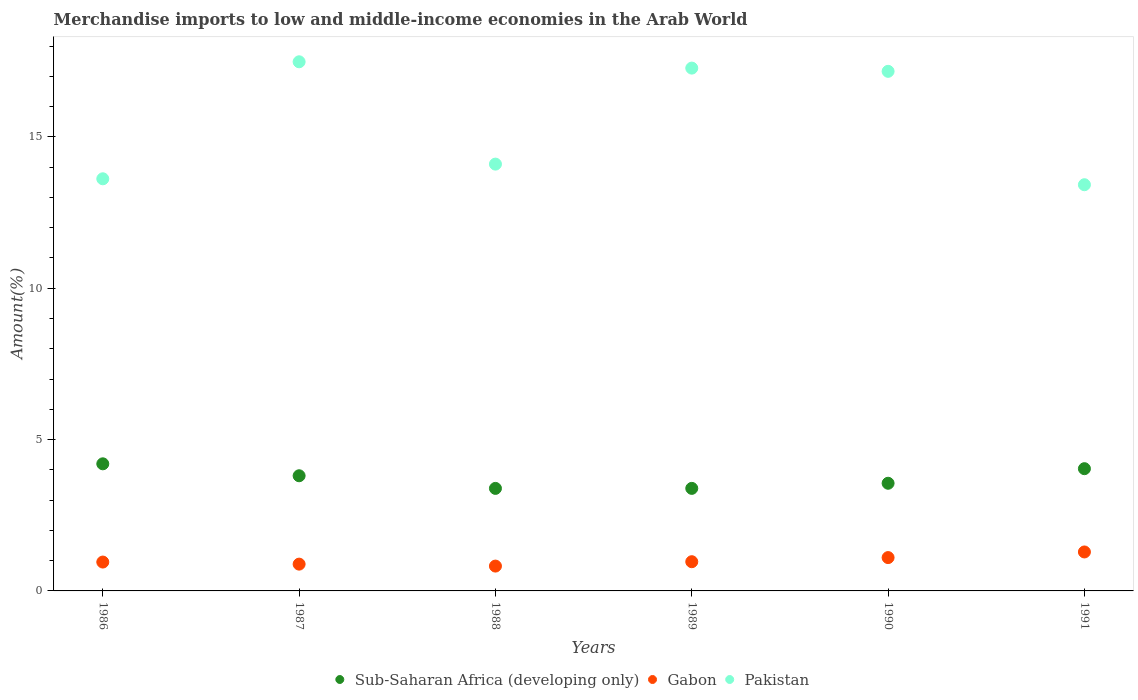How many different coloured dotlines are there?
Give a very brief answer. 3. What is the percentage of amount earned from merchandise imports in Sub-Saharan Africa (developing only) in 1991?
Your answer should be compact. 4.04. Across all years, what is the maximum percentage of amount earned from merchandise imports in Gabon?
Offer a very short reply. 1.29. Across all years, what is the minimum percentage of amount earned from merchandise imports in Pakistan?
Provide a succinct answer. 13.42. In which year was the percentage of amount earned from merchandise imports in Sub-Saharan Africa (developing only) maximum?
Offer a very short reply. 1986. What is the total percentage of amount earned from merchandise imports in Sub-Saharan Africa (developing only) in the graph?
Your answer should be very brief. 22.37. What is the difference between the percentage of amount earned from merchandise imports in Sub-Saharan Africa (developing only) in 1986 and that in 1987?
Offer a terse response. 0.39. What is the difference between the percentage of amount earned from merchandise imports in Gabon in 1991 and the percentage of amount earned from merchandise imports in Pakistan in 1990?
Offer a very short reply. -15.88. What is the average percentage of amount earned from merchandise imports in Sub-Saharan Africa (developing only) per year?
Keep it short and to the point. 3.73. In the year 1987, what is the difference between the percentage of amount earned from merchandise imports in Pakistan and percentage of amount earned from merchandise imports in Gabon?
Provide a succinct answer. 16.6. In how many years, is the percentage of amount earned from merchandise imports in Pakistan greater than 15 %?
Your answer should be compact. 3. What is the ratio of the percentage of amount earned from merchandise imports in Pakistan in 1986 to that in 1989?
Your response must be concise. 0.79. What is the difference between the highest and the second highest percentage of amount earned from merchandise imports in Pakistan?
Give a very brief answer. 0.21. What is the difference between the highest and the lowest percentage of amount earned from merchandise imports in Sub-Saharan Africa (developing only)?
Offer a terse response. 0.81. Is the sum of the percentage of amount earned from merchandise imports in Gabon in 1990 and 1991 greater than the maximum percentage of amount earned from merchandise imports in Pakistan across all years?
Your response must be concise. No. Is it the case that in every year, the sum of the percentage of amount earned from merchandise imports in Gabon and percentage of amount earned from merchandise imports in Sub-Saharan Africa (developing only)  is greater than the percentage of amount earned from merchandise imports in Pakistan?
Provide a short and direct response. No. Does the percentage of amount earned from merchandise imports in Sub-Saharan Africa (developing only) monotonically increase over the years?
Your answer should be compact. No. Is the percentage of amount earned from merchandise imports in Sub-Saharan Africa (developing only) strictly less than the percentage of amount earned from merchandise imports in Pakistan over the years?
Make the answer very short. Yes. What is the difference between two consecutive major ticks on the Y-axis?
Ensure brevity in your answer.  5. Does the graph contain any zero values?
Keep it short and to the point. No. Does the graph contain grids?
Your answer should be compact. No. How are the legend labels stacked?
Make the answer very short. Horizontal. What is the title of the graph?
Ensure brevity in your answer.  Merchandise imports to low and middle-income economies in the Arab World. Does "Bahrain" appear as one of the legend labels in the graph?
Your answer should be compact. No. What is the label or title of the X-axis?
Make the answer very short. Years. What is the label or title of the Y-axis?
Offer a terse response. Amount(%). What is the Amount(%) of Sub-Saharan Africa (developing only) in 1986?
Provide a succinct answer. 4.2. What is the Amount(%) in Gabon in 1986?
Your response must be concise. 0.95. What is the Amount(%) of Pakistan in 1986?
Your answer should be compact. 13.62. What is the Amount(%) of Sub-Saharan Africa (developing only) in 1987?
Give a very brief answer. 3.8. What is the Amount(%) in Gabon in 1987?
Make the answer very short. 0.89. What is the Amount(%) of Pakistan in 1987?
Keep it short and to the point. 17.48. What is the Amount(%) in Sub-Saharan Africa (developing only) in 1988?
Ensure brevity in your answer.  3.39. What is the Amount(%) of Gabon in 1988?
Your response must be concise. 0.82. What is the Amount(%) of Pakistan in 1988?
Your answer should be very brief. 14.1. What is the Amount(%) of Sub-Saharan Africa (developing only) in 1989?
Your answer should be compact. 3.39. What is the Amount(%) of Gabon in 1989?
Keep it short and to the point. 0.97. What is the Amount(%) in Pakistan in 1989?
Give a very brief answer. 17.27. What is the Amount(%) in Sub-Saharan Africa (developing only) in 1990?
Make the answer very short. 3.56. What is the Amount(%) of Gabon in 1990?
Your answer should be compact. 1.1. What is the Amount(%) of Pakistan in 1990?
Your response must be concise. 17.17. What is the Amount(%) in Sub-Saharan Africa (developing only) in 1991?
Ensure brevity in your answer.  4.04. What is the Amount(%) in Gabon in 1991?
Your response must be concise. 1.29. What is the Amount(%) of Pakistan in 1991?
Your response must be concise. 13.42. Across all years, what is the maximum Amount(%) in Sub-Saharan Africa (developing only)?
Your answer should be very brief. 4.2. Across all years, what is the maximum Amount(%) in Gabon?
Your answer should be very brief. 1.29. Across all years, what is the maximum Amount(%) in Pakistan?
Offer a very short reply. 17.48. Across all years, what is the minimum Amount(%) in Sub-Saharan Africa (developing only)?
Ensure brevity in your answer.  3.39. Across all years, what is the minimum Amount(%) in Gabon?
Make the answer very short. 0.82. Across all years, what is the minimum Amount(%) of Pakistan?
Offer a very short reply. 13.42. What is the total Amount(%) in Sub-Saharan Africa (developing only) in the graph?
Offer a terse response. 22.37. What is the total Amount(%) in Gabon in the graph?
Your answer should be compact. 6.01. What is the total Amount(%) of Pakistan in the graph?
Your answer should be very brief. 93.05. What is the difference between the Amount(%) in Sub-Saharan Africa (developing only) in 1986 and that in 1987?
Your answer should be compact. 0.39. What is the difference between the Amount(%) of Gabon in 1986 and that in 1987?
Provide a succinct answer. 0.07. What is the difference between the Amount(%) of Pakistan in 1986 and that in 1987?
Provide a succinct answer. -3.87. What is the difference between the Amount(%) in Sub-Saharan Africa (developing only) in 1986 and that in 1988?
Make the answer very short. 0.81. What is the difference between the Amount(%) in Gabon in 1986 and that in 1988?
Your response must be concise. 0.13. What is the difference between the Amount(%) in Pakistan in 1986 and that in 1988?
Give a very brief answer. -0.48. What is the difference between the Amount(%) in Sub-Saharan Africa (developing only) in 1986 and that in 1989?
Your response must be concise. 0.81. What is the difference between the Amount(%) in Gabon in 1986 and that in 1989?
Your answer should be compact. -0.01. What is the difference between the Amount(%) of Pakistan in 1986 and that in 1989?
Your answer should be very brief. -3.66. What is the difference between the Amount(%) of Sub-Saharan Africa (developing only) in 1986 and that in 1990?
Provide a short and direct response. 0.64. What is the difference between the Amount(%) of Gabon in 1986 and that in 1990?
Offer a very short reply. -0.15. What is the difference between the Amount(%) in Pakistan in 1986 and that in 1990?
Keep it short and to the point. -3.55. What is the difference between the Amount(%) of Sub-Saharan Africa (developing only) in 1986 and that in 1991?
Ensure brevity in your answer.  0.16. What is the difference between the Amount(%) of Gabon in 1986 and that in 1991?
Keep it short and to the point. -0.33. What is the difference between the Amount(%) of Pakistan in 1986 and that in 1991?
Your response must be concise. 0.2. What is the difference between the Amount(%) in Sub-Saharan Africa (developing only) in 1987 and that in 1988?
Keep it short and to the point. 0.42. What is the difference between the Amount(%) in Gabon in 1987 and that in 1988?
Provide a succinct answer. 0.06. What is the difference between the Amount(%) of Pakistan in 1987 and that in 1988?
Offer a very short reply. 3.38. What is the difference between the Amount(%) of Sub-Saharan Africa (developing only) in 1987 and that in 1989?
Your response must be concise. 0.42. What is the difference between the Amount(%) in Gabon in 1987 and that in 1989?
Make the answer very short. -0.08. What is the difference between the Amount(%) of Pakistan in 1987 and that in 1989?
Provide a succinct answer. 0.21. What is the difference between the Amount(%) in Sub-Saharan Africa (developing only) in 1987 and that in 1990?
Offer a very short reply. 0.25. What is the difference between the Amount(%) of Gabon in 1987 and that in 1990?
Your answer should be very brief. -0.22. What is the difference between the Amount(%) in Pakistan in 1987 and that in 1990?
Ensure brevity in your answer.  0.32. What is the difference between the Amount(%) of Sub-Saharan Africa (developing only) in 1987 and that in 1991?
Offer a terse response. -0.23. What is the difference between the Amount(%) of Gabon in 1987 and that in 1991?
Provide a succinct answer. -0.4. What is the difference between the Amount(%) in Pakistan in 1987 and that in 1991?
Give a very brief answer. 4.06. What is the difference between the Amount(%) in Sub-Saharan Africa (developing only) in 1988 and that in 1989?
Your answer should be very brief. -0. What is the difference between the Amount(%) of Gabon in 1988 and that in 1989?
Make the answer very short. -0.14. What is the difference between the Amount(%) of Pakistan in 1988 and that in 1989?
Offer a very short reply. -3.17. What is the difference between the Amount(%) in Sub-Saharan Africa (developing only) in 1988 and that in 1990?
Your response must be concise. -0.17. What is the difference between the Amount(%) of Gabon in 1988 and that in 1990?
Offer a very short reply. -0.28. What is the difference between the Amount(%) in Pakistan in 1988 and that in 1990?
Keep it short and to the point. -3.07. What is the difference between the Amount(%) of Sub-Saharan Africa (developing only) in 1988 and that in 1991?
Your answer should be very brief. -0.65. What is the difference between the Amount(%) in Gabon in 1988 and that in 1991?
Provide a succinct answer. -0.47. What is the difference between the Amount(%) of Pakistan in 1988 and that in 1991?
Offer a very short reply. 0.68. What is the difference between the Amount(%) of Sub-Saharan Africa (developing only) in 1989 and that in 1990?
Your answer should be very brief. -0.17. What is the difference between the Amount(%) in Gabon in 1989 and that in 1990?
Offer a very short reply. -0.14. What is the difference between the Amount(%) of Pakistan in 1989 and that in 1990?
Provide a short and direct response. 0.11. What is the difference between the Amount(%) in Sub-Saharan Africa (developing only) in 1989 and that in 1991?
Make the answer very short. -0.65. What is the difference between the Amount(%) of Gabon in 1989 and that in 1991?
Give a very brief answer. -0.32. What is the difference between the Amount(%) of Pakistan in 1989 and that in 1991?
Your answer should be very brief. 3.85. What is the difference between the Amount(%) in Sub-Saharan Africa (developing only) in 1990 and that in 1991?
Your answer should be very brief. -0.48. What is the difference between the Amount(%) in Gabon in 1990 and that in 1991?
Offer a terse response. -0.19. What is the difference between the Amount(%) of Pakistan in 1990 and that in 1991?
Ensure brevity in your answer.  3.75. What is the difference between the Amount(%) of Sub-Saharan Africa (developing only) in 1986 and the Amount(%) of Gabon in 1987?
Your response must be concise. 3.31. What is the difference between the Amount(%) of Sub-Saharan Africa (developing only) in 1986 and the Amount(%) of Pakistan in 1987?
Your answer should be very brief. -13.28. What is the difference between the Amount(%) in Gabon in 1986 and the Amount(%) in Pakistan in 1987?
Provide a succinct answer. -16.53. What is the difference between the Amount(%) of Sub-Saharan Africa (developing only) in 1986 and the Amount(%) of Gabon in 1988?
Make the answer very short. 3.38. What is the difference between the Amount(%) in Sub-Saharan Africa (developing only) in 1986 and the Amount(%) in Pakistan in 1988?
Your answer should be compact. -9.9. What is the difference between the Amount(%) in Gabon in 1986 and the Amount(%) in Pakistan in 1988?
Make the answer very short. -13.15. What is the difference between the Amount(%) of Sub-Saharan Africa (developing only) in 1986 and the Amount(%) of Gabon in 1989?
Your response must be concise. 3.23. What is the difference between the Amount(%) of Sub-Saharan Africa (developing only) in 1986 and the Amount(%) of Pakistan in 1989?
Provide a succinct answer. -13.07. What is the difference between the Amount(%) of Gabon in 1986 and the Amount(%) of Pakistan in 1989?
Keep it short and to the point. -16.32. What is the difference between the Amount(%) of Sub-Saharan Africa (developing only) in 1986 and the Amount(%) of Gabon in 1990?
Make the answer very short. 3.1. What is the difference between the Amount(%) in Sub-Saharan Africa (developing only) in 1986 and the Amount(%) in Pakistan in 1990?
Your response must be concise. -12.97. What is the difference between the Amount(%) of Gabon in 1986 and the Amount(%) of Pakistan in 1990?
Give a very brief answer. -16.21. What is the difference between the Amount(%) of Sub-Saharan Africa (developing only) in 1986 and the Amount(%) of Gabon in 1991?
Offer a very short reply. 2.91. What is the difference between the Amount(%) in Sub-Saharan Africa (developing only) in 1986 and the Amount(%) in Pakistan in 1991?
Keep it short and to the point. -9.22. What is the difference between the Amount(%) of Gabon in 1986 and the Amount(%) of Pakistan in 1991?
Provide a succinct answer. -12.47. What is the difference between the Amount(%) of Sub-Saharan Africa (developing only) in 1987 and the Amount(%) of Gabon in 1988?
Make the answer very short. 2.98. What is the difference between the Amount(%) of Sub-Saharan Africa (developing only) in 1987 and the Amount(%) of Pakistan in 1988?
Provide a succinct answer. -10.3. What is the difference between the Amount(%) in Gabon in 1987 and the Amount(%) in Pakistan in 1988?
Make the answer very short. -13.22. What is the difference between the Amount(%) in Sub-Saharan Africa (developing only) in 1987 and the Amount(%) in Gabon in 1989?
Offer a very short reply. 2.84. What is the difference between the Amount(%) in Sub-Saharan Africa (developing only) in 1987 and the Amount(%) in Pakistan in 1989?
Keep it short and to the point. -13.47. What is the difference between the Amount(%) in Gabon in 1987 and the Amount(%) in Pakistan in 1989?
Provide a succinct answer. -16.39. What is the difference between the Amount(%) in Sub-Saharan Africa (developing only) in 1987 and the Amount(%) in Gabon in 1990?
Offer a very short reply. 2.7. What is the difference between the Amount(%) of Sub-Saharan Africa (developing only) in 1987 and the Amount(%) of Pakistan in 1990?
Offer a terse response. -13.36. What is the difference between the Amount(%) in Gabon in 1987 and the Amount(%) in Pakistan in 1990?
Your answer should be very brief. -16.28. What is the difference between the Amount(%) of Sub-Saharan Africa (developing only) in 1987 and the Amount(%) of Gabon in 1991?
Your answer should be very brief. 2.52. What is the difference between the Amount(%) in Sub-Saharan Africa (developing only) in 1987 and the Amount(%) in Pakistan in 1991?
Offer a very short reply. -9.61. What is the difference between the Amount(%) of Gabon in 1987 and the Amount(%) of Pakistan in 1991?
Offer a very short reply. -12.53. What is the difference between the Amount(%) of Sub-Saharan Africa (developing only) in 1988 and the Amount(%) of Gabon in 1989?
Provide a short and direct response. 2.42. What is the difference between the Amount(%) in Sub-Saharan Africa (developing only) in 1988 and the Amount(%) in Pakistan in 1989?
Provide a succinct answer. -13.88. What is the difference between the Amount(%) in Gabon in 1988 and the Amount(%) in Pakistan in 1989?
Your answer should be compact. -16.45. What is the difference between the Amount(%) of Sub-Saharan Africa (developing only) in 1988 and the Amount(%) of Gabon in 1990?
Give a very brief answer. 2.29. What is the difference between the Amount(%) in Sub-Saharan Africa (developing only) in 1988 and the Amount(%) in Pakistan in 1990?
Ensure brevity in your answer.  -13.78. What is the difference between the Amount(%) of Gabon in 1988 and the Amount(%) of Pakistan in 1990?
Provide a succinct answer. -16.35. What is the difference between the Amount(%) in Sub-Saharan Africa (developing only) in 1988 and the Amount(%) in Pakistan in 1991?
Ensure brevity in your answer.  -10.03. What is the difference between the Amount(%) of Gabon in 1988 and the Amount(%) of Pakistan in 1991?
Keep it short and to the point. -12.6. What is the difference between the Amount(%) in Sub-Saharan Africa (developing only) in 1989 and the Amount(%) in Gabon in 1990?
Your response must be concise. 2.29. What is the difference between the Amount(%) in Sub-Saharan Africa (developing only) in 1989 and the Amount(%) in Pakistan in 1990?
Give a very brief answer. -13.78. What is the difference between the Amount(%) of Gabon in 1989 and the Amount(%) of Pakistan in 1990?
Make the answer very short. -16.2. What is the difference between the Amount(%) of Sub-Saharan Africa (developing only) in 1989 and the Amount(%) of Gabon in 1991?
Ensure brevity in your answer.  2.1. What is the difference between the Amount(%) in Sub-Saharan Africa (developing only) in 1989 and the Amount(%) in Pakistan in 1991?
Ensure brevity in your answer.  -10.03. What is the difference between the Amount(%) of Gabon in 1989 and the Amount(%) of Pakistan in 1991?
Your answer should be very brief. -12.45. What is the difference between the Amount(%) of Sub-Saharan Africa (developing only) in 1990 and the Amount(%) of Gabon in 1991?
Provide a short and direct response. 2.27. What is the difference between the Amount(%) in Sub-Saharan Africa (developing only) in 1990 and the Amount(%) in Pakistan in 1991?
Your answer should be very brief. -9.86. What is the difference between the Amount(%) of Gabon in 1990 and the Amount(%) of Pakistan in 1991?
Provide a short and direct response. -12.32. What is the average Amount(%) of Sub-Saharan Africa (developing only) per year?
Give a very brief answer. 3.73. What is the average Amount(%) in Gabon per year?
Give a very brief answer. 1. What is the average Amount(%) of Pakistan per year?
Offer a very short reply. 15.51. In the year 1986, what is the difference between the Amount(%) in Sub-Saharan Africa (developing only) and Amount(%) in Gabon?
Provide a succinct answer. 3.25. In the year 1986, what is the difference between the Amount(%) of Sub-Saharan Africa (developing only) and Amount(%) of Pakistan?
Offer a terse response. -9.42. In the year 1986, what is the difference between the Amount(%) of Gabon and Amount(%) of Pakistan?
Your response must be concise. -12.66. In the year 1987, what is the difference between the Amount(%) of Sub-Saharan Africa (developing only) and Amount(%) of Gabon?
Ensure brevity in your answer.  2.92. In the year 1987, what is the difference between the Amount(%) in Sub-Saharan Africa (developing only) and Amount(%) in Pakistan?
Keep it short and to the point. -13.68. In the year 1987, what is the difference between the Amount(%) in Gabon and Amount(%) in Pakistan?
Your answer should be compact. -16.6. In the year 1988, what is the difference between the Amount(%) in Sub-Saharan Africa (developing only) and Amount(%) in Gabon?
Your response must be concise. 2.57. In the year 1988, what is the difference between the Amount(%) of Sub-Saharan Africa (developing only) and Amount(%) of Pakistan?
Make the answer very short. -10.71. In the year 1988, what is the difference between the Amount(%) in Gabon and Amount(%) in Pakistan?
Provide a short and direct response. -13.28. In the year 1989, what is the difference between the Amount(%) in Sub-Saharan Africa (developing only) and Amount(%) in Gabon?
Give a very brief answer. 2.42. In the year 1989, what is the difference between the Amount(%) of Sub-Saharan Africa (developing only) and Amount(%) of Pakistan?
Offer a very short reply. -13.88. In the year 1989, what is the difference between the Amount(%) of Gabon and Amount(%) of Pakistan?
Your answer should be very brief. -16.31. In the year 1990, what is the difference between the Amount(%) in Sub-Saharan Africa (developing only) and Amount(%) in Gabon?
Keep it short and to the point. 2.46. In the year 1990, what is the difference between the Amount(%) of Sub-Saharan Africa (developing only) and Amount(%) of Pakistan?
Ensure brevity in your answer.  -13.61. In the year 1990, what is the difference between the Amount(%) of Gabon and Amount(%) of Pakistan?
Provide a succinct answer. -16.06. In the year 1991, what is the difference between the Amount(%) in Sub-Saharan Africa (developing only) and Amount(%) in Gabon?
Your response must be concise. 2.75. In the year 1991, what is the difference between the Amount(%) of Sub-Saharan Africa (developing only) and Amount(%) of Pakistan?
Your answer should be very brief. -9.38. In the year 1991, what is the difference between the Amount(%) in Gabon and Amount(%) in Pakistan?
Give a very brief answer. -12.13. What is the ratio of the Amount(%) of Sub-Saharan Africa (developing only) in 1986 to that in 1987?
Your response must be concise. 1.1. What is the ratio of the Amount(%) of Gabon in 1986 to that in 1987?
Ensure brevity in your answer.  1.08. What is the ratio of the Amount(%) of Pakistan in 1986 to that in 1987?
Ensure brevity in your answer.  0.78. What is the ratio of the Amount(%) in Sub-Saharan Africa (developing only) in 1986 to that in 1988?
Provide a succinct answer. 1.24. What is the ratio of the Amount(%) in Gabon in 1986 to that in 1988?
Offer a very short reply. 1.16. What is the ratio of the Amount(%) of Pakistan in 1986 to that in 1988?
Offer a very short reply. 0.97. What is the ratio of the Amount(%) of Sub-Saharan Africa (developing only) in 1986 to that in 1989?
Offer a terse response. 1.24. What is the ratio of the Amount(%) of Pakistan in 1986 to that in 1989?
Your answer should be very brief. 0.79. What is the ratio of the Amount(%) in Sub-Saharan Africa (developing only) in 1986 to that in 1990?
Your response must be concise. 1.18. What is the ratio of the Amount(%) in Gabon in 1986 to that in 1990?
Offer a very short reply. 0.87. What is the ratio of the Amount(%) in Pakistan in 1986 to that in 1990?
Offer a terse response. 0.79. What is the ratio of the Amount(%) of Sub-Saharan Africa (developing only) in 1986 to that in 1991?
Your answer should be very brief. 1.04. What is the ratio of the Amount(%) of Gabon in 1986 to that in 1991?
Make the answer very short. 0.74. What is the ratio of the Amount(%) in Pakistan in 1986 to that in 1991?
Offer a very short reply. 1.01. What is the ratio of the Amount(%) in Sub-Saharan Africa (developing only) in 1987 to that in 1988?
Provide a short and direct response. 1.12. What is the ratio of the Amount(%) of Gabon in 1987 to that in 1988?
Ensure brevity in your answer.  1.08. What is the ratio of the Amount(%) in Pakistan in 1987 to that in 1988?
Offer a terse response. 1.24. What is the ratio of the Amount(%) in Sub-Saharan Africa (developing only) in 1987 to that in 1989?
Make the answer very short. 1.12. What is the ratio of the Amount(%) in Gabon in 1987 to that in 1989?
Give a very brief answer. 0.92. What is the ratio of the Amount(%) of Pakistan in 1987 to that in 1989?
Your response must be concise. 1.01. What is the ratio of the Amount(%) in Sub-Saharan Africa (developing only) in 1987 to that in 1990?
Offer a very short reply. 1.07. What is the ratio of the Amount(%) in Gabon in 1987 to that in 1990?
Offer a terse response. 0.8. What is the ratio of the Amount(%) of Pakistan in 1987 to that in 1990?
Offer a terse response. 1.02. What is the ratio of the Amount(%) in Sub-Saharan Africa (developing only) in 1987 to that in 1991?
Provide a short and direct response. 0.94. What is the ratio of the Amount(%) in Gabon in 1987 to that in 1991?
Your answer should be very brief. 0.69. What is the ratio of the Amount(%) in Pakistan in 1987 to that in 1991?
Offer a very short reply. 1.3. What is the ratio of the Amount(%) of Sub-Saharan Africa (developing only) in 1988 to that in 1989?
Your answer should be very brief. 1. What is the ratio of the Amount(%) of Gabon in 1988 to that in 1989?
Your answer should be compact. 0.85. What is the ratio of the Amount(%) of Pakistan in 1988 to that in 1989?
Provide a short and direct response. 0.82. What is the ratio of the Amount(%) of Sub-Saharan Africa (developing only) in 1988 to that in 1990?
Offer a very short reply. 0.95. What is the ratio of the Amount(%) in Gabon in 1988 to that in 1990?
Give a very brief answer. 0.74. What is the ratio of the Amount(%) of Pakistan in 1988 to that in 1990?
Your answer should be compact. 0.82. What is the ratio of the Amount(%) of Sub-Saharan Africa (developing only) in 1988 to that in 1991?
Your answer should be compact. 0.84. What is the ratio of the Amount(%) of Gabon in 1988 to that in 1991?
Provide a succinct answer. 0.64. What is the ratio of the Amount(%) in Pakistan in 1988 to that in 1991?
Your response must be concise. 1.05. What is the ratio of the Amount(%) in Sub-Saharan Africa (developing only) in 1989 to that in 1990?
Offer a very short reply. 0.95. What is the ratio of the Amount(%) in Gabon in 1989 to that in 1990?
Provide a succinct answer. 0.88. What is the ratio of the Amount(%) of Sub-Saharan Africa (developing only) in 1989 to that in 1991?
Offer a terse response. 0.84. What is the ratio of the Amount(%) of Gabon in 1989 to that in 1991?
Ensure brevity in your answer.  0.75. What is the ratio of the Amount(%) in Pakistan in 1989 to that in 1991?
Offer a terse response. 1.29. What is the ratio of the Amount(%) of Sub-Saharan Africa (developing only) in 1990 to that in 1991?
Your answer should be compact. 0.88. What is the ratio of the Amount(%) in Gabon in 1990 to that in 1991?
Provide a succinct answer. 0.86. What is the ratio of the Amount(%) of Pakistan in 1990 to that in 1991?
Offer a terse response. 1.28. What is the difference between the highest and the second highest Amount(%) of Sub-Saharan Africa (developing only)?
Make the answer very short. 0.16. What is the difference between the highest and the second highest Amount(%) of Gabon?
Offer a terse response. 0.19. What is the difference between the highest and the second highest Amount(%) of Pakistan?
Ensure brevity in your answer.  0.21. What is the difference between the highest and the lowest Amount(%) of Sub-Saharan Africa (developing only)?
Offer a terse response. 0.81. What is the difference between the highest and the lowest Amount(%) of Gabon?
Provide a short and direct response. 0.47. What is the difference between the highest and the lowest Amount(%) of Pakistan?
Offer a terse response. 4.06. 